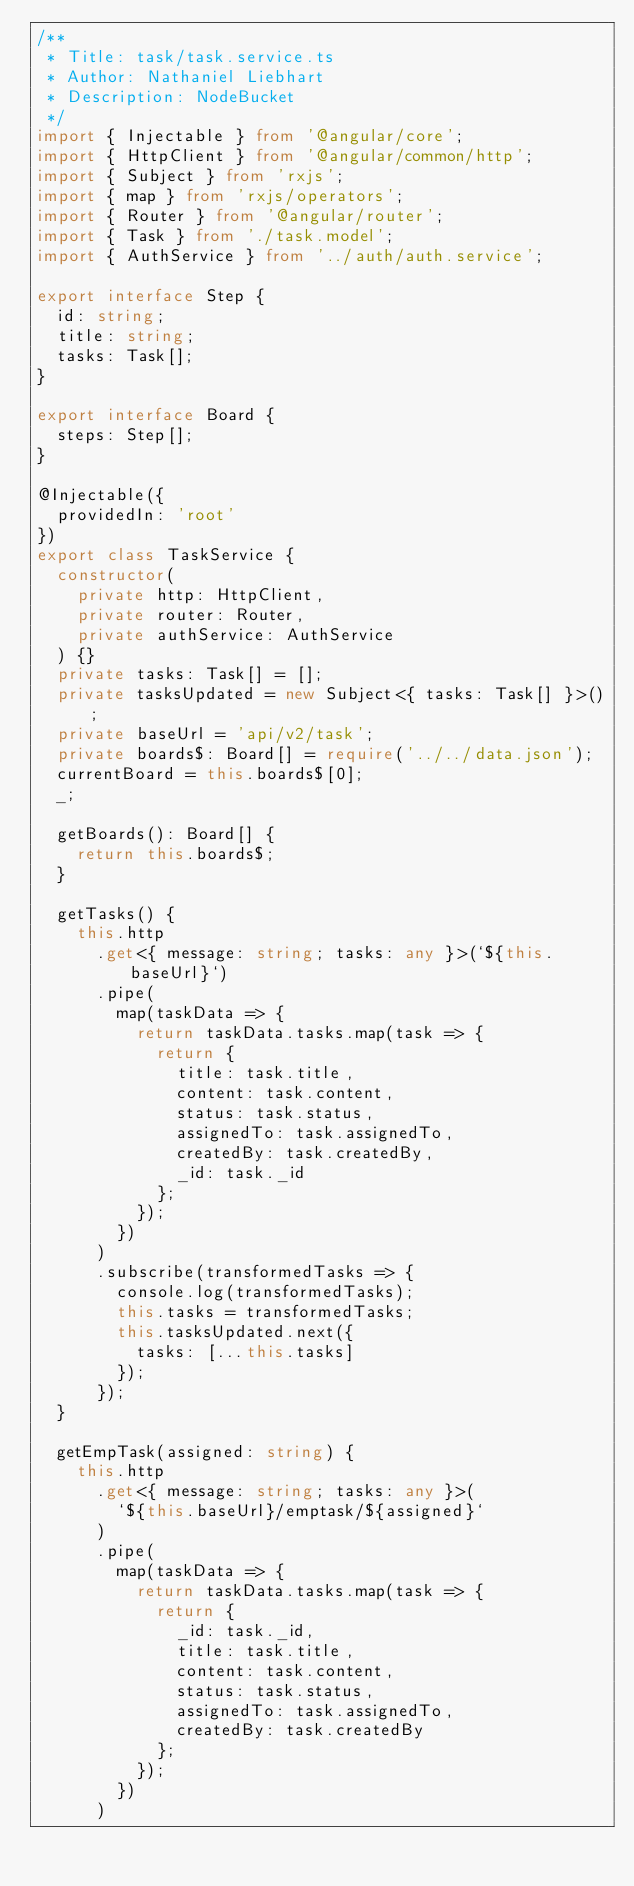<code> <loc_0><loc_0><loc_500><loc_500><_TypeScript_>/**
 * Title: task/task.service.ts
 * Author: Nathaniel Liebhart
 * Description: NodeBucket
 */
import { Injectable } from '@angular/core';
import { HttpClient } from '@angular/common/http';
import { Subject } from 'rxjs';
import { map } from 'rxjs/operators';
import { Router } from '@angular/router';
import { Task } from './task.model';
import { AuthService } from '../auth/auth.service';

export interface Step {
  id: string;
  title: string;
  tasks: Task[];
}

export interface Board {
  steps: Step[];
}

@Injectable({
  providedIn: 'root'
})
export class TaskService {
  constructor(
    private http: HttpClient,
    private router: Router,
    private authService: AuthService
  ) {}
  private tasks: Task[] = [];
  private tasksUpdated = new Subject<{ tasks: Task[] }>();
  private baseUrl = 'api/v2/task';
  private boards$: Board[] = require('../../data.json');
  currentBoard = this.boards$[0];
  _;

  getBoards(): Board[] {
    return this.boards$;
  }

  getTasks() {
    this.http
      .get<{ message: string; tasks: any }>(`${this.baseUrl}`)
      .pipe(
        map(taskData => {
          return taskData.tasks.map(task => {
            return {
              title: task.title,
              content: task.content,
              status: task.status,
              assignedTo: task.assignedTo,
              createdBy: task.createdBy,
              _id: task._id
            };
          });
        })
      )
      .subscribe(transformedTasks => {
        console.log(transformedTasks);
        this.tasks = transformedTasks;
        this.tasksUpdated.next({
          tasks: [...this.tasks]
        });
      });
  }

  getEmpTask(assigned: string) {
    this.http
      .get<{ message: string; tasks: any }>(
        `${this.baseUrl}/emptask/${assigned}`
      )
      .pipe(
        map(taskData => {
          return taskData.tasks.map(task => {
            return {
              _id: task._id,
              title: task.title,
              content: task.content,
              status: task.status,
              assignedTo: task.assignedTo,
              createdBy: task.createdBy
            };
          });
        })
      )</code> 